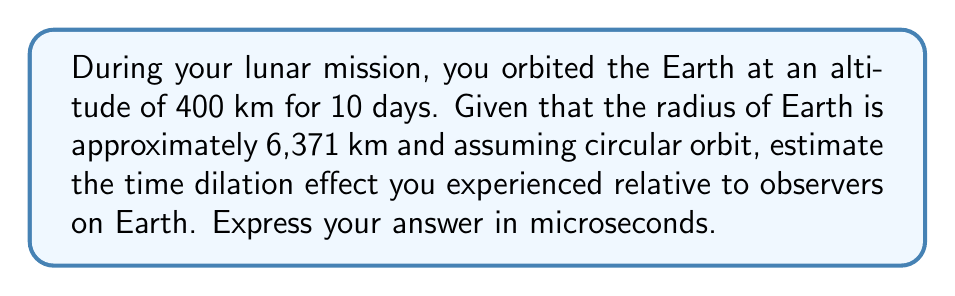Help me with this question. To solve this problem, we'll use the time dilation formula from special relativity and the orbital velocity formula. Let's break it down step-by-step:

1) First, we need to calculate the orbital velocity. The formula for orbital velocity is:

   $$v = \sqrt{\frac{GM}{r}}$$

   where $G$ is the gravitational constant, $M$ is the mass of Earth, and $r$ is the orbital radius.

2) We don't need to know $G$ or $M$ explicitly. Instead, we can use the fact that for low Earth orbit:

   $$v \approx \sqrt{\frac{GM}{R}} \sqrt{\frac{R}{r}}$$

   where $R$ is Earth's radius and $r$ is the orbital radius.

3) We know that $\sqrt{\frac{GM}{R}} \approx 7.9$ km/s (the velocity needed to orbit at Earth's surface).

4) The orbital radius $r$ is Earth's radius plus the orbital altitude:
   
   $r = 6371 \text{ km} + 400 \text{ km} = 6771 \text{ km}$

5) Now we can calculate the orbital velocity:

   $$v \approx 7.9 \text{ km/s} \sqrt{\frac{6371}{6771}} \approx 7.67 \text{ km/s}$$

6) The time dilation formula is:

   $$\Delta t = t_0 \sqrt{1 - \frac{v^2}{c^2}}$$

   where $\Delta t$ is the time experienced in orbit, $t_0$ is the time passed on Earth, and $c$ is the speed of light.

7) Rearranging this, we get:

   $$t_0 - \Delta t = t_0 (1 - \sqrt{1 - \frac{v^2}{c^2}})$$

8) The right side of this equation is approximately equal to:

   $$t_0 \frac{v^2}{2c^2}$$

9) Plugging in our values:

   $t_0 = 10 \text{ days} = 864000 \text{ seconds}$
   $v = 7.67 \text{ km/s} = 7670 \text{ m/s}$
   $c = 299792458 \text{ m/s}$

10) The time difference is:

    $$864000 \cdot \frac{7670^2}{2 \cdot 299792458^2} \approx 0.000327 \text{ seconds}$$

11) Converting to microseconds:

    $0.000327 \text{ seconds} \cdot 10^6 = 327 \text{ microseconds}$
Answer: 327 microseconds 